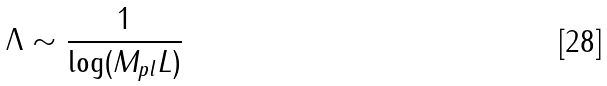Convert formula to latex. <formula><loc_0><loc_0><loc_500><loc_500>\Lambda \sim \frac { 1 } { \log ( M _ { p l } L ) }</formula> 